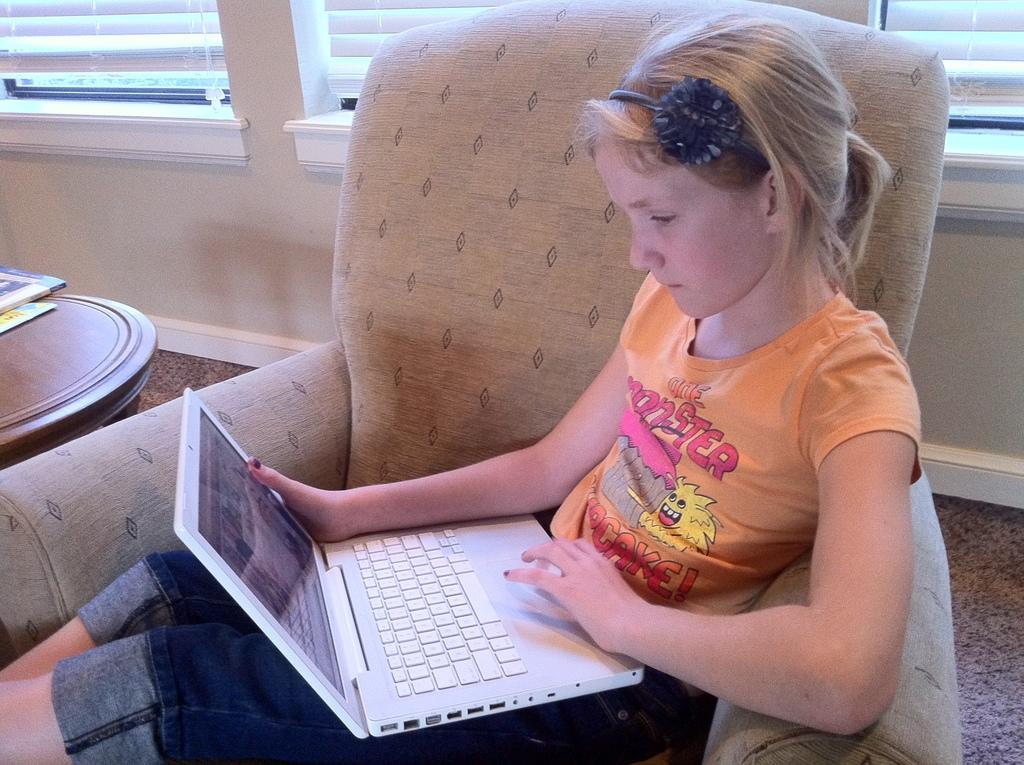What is the person in the image doing? The person is sitting on a chair and holding a laptop. What else can be seen on the left side of the image? There are books on a table on the left side of the image. What is visible in the background of the image? There is a grille visible in the background of the image. What type of fiction is the person reading in the image? There is no book or reading material visible in the image, so it cannot be determined what type of fiction the person might be reading. 